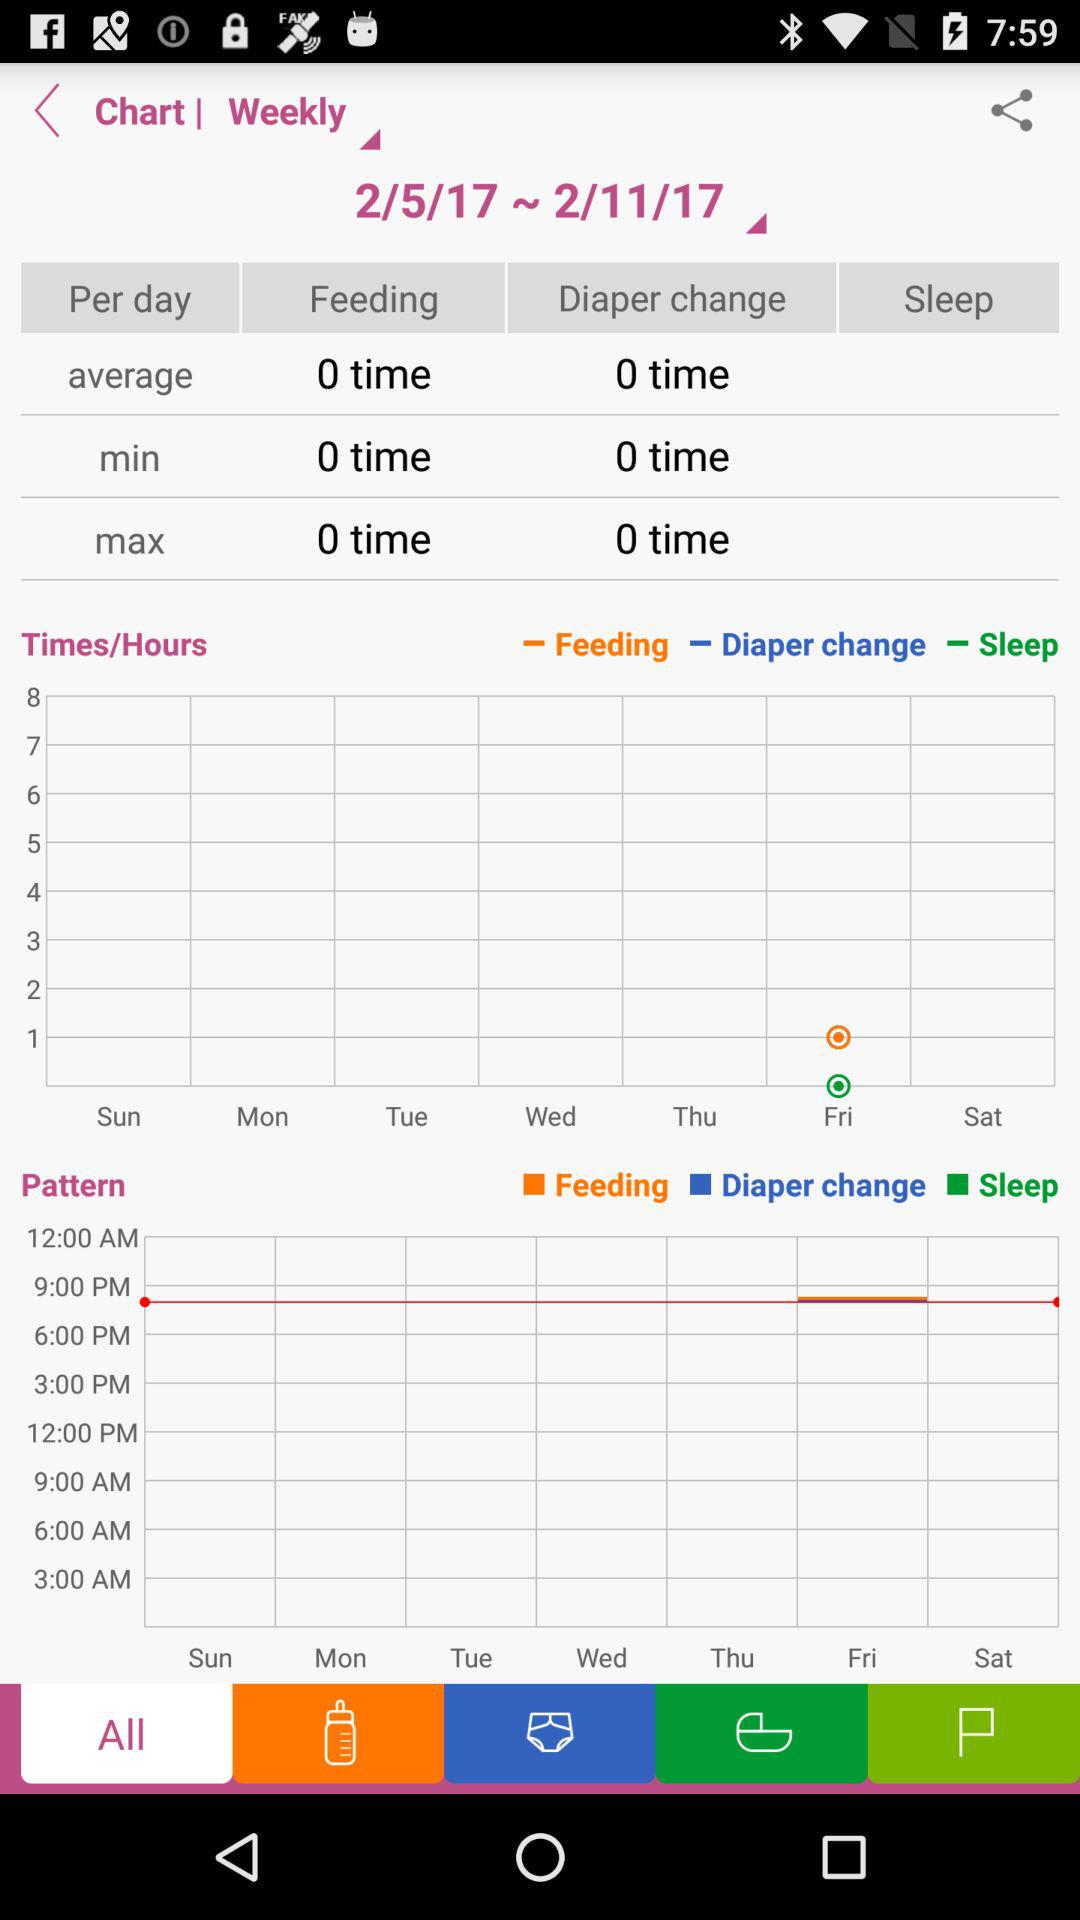What is the selected date range? The selected date range is from February 5, 2017 to February 11, 2017. 